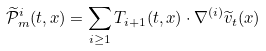Convert formula to latex. <formula><loc_0><loc_0><loc_500><loc_500>\widetilde { \mathcal { P } } _ { m } ^ { i } ( t , x ) = \sum _ { i \geq 1 } { { T } _ { i + 1 } ( t , x ) \cdot \nabla ^ { ( i ) } \widetilde { v } _ { t } ( x ) }</formula> 